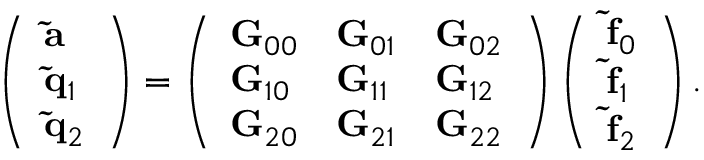<formula> <loc_0><loc_0><loc_500><loc_500>\left ( \begin{array} { l } { { \tilde { a } } } \\ { { \tilde { q } } _ { 1 } } \\ { { \tilde { q } } _ { 2 } } \end{array} \right ) = \left ( \begin{array} { l l l } { { G } _ { 0 0 } } & { { G } _ { 0 1 } } & { { G } _ { 0 2 } } \\ { { G } _ { 1 0 } } & { { G } _ { 1 1 } } & { { G } _ { 1 2 } } \\ { { G } _ { 2 0 } } & { { G } _ { 2 1 } } & { { G } _ { 2 2 } } \end{array} \right ) \left ( \begin{array} { l } { { \tilde { f } } _ { 0 } } \\ { { \tilde { f } } _ { 1 } } \\ { { \tilde { f } } _ { 2 } } \end{array} \right ) .</formula> 